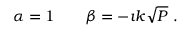Convert formula to latex. <formula><loc_0><loc_0><loc_500><loc_500>\alpha = 1 \quad \beta = - \i k \sqrt { P } \ .</formula> 